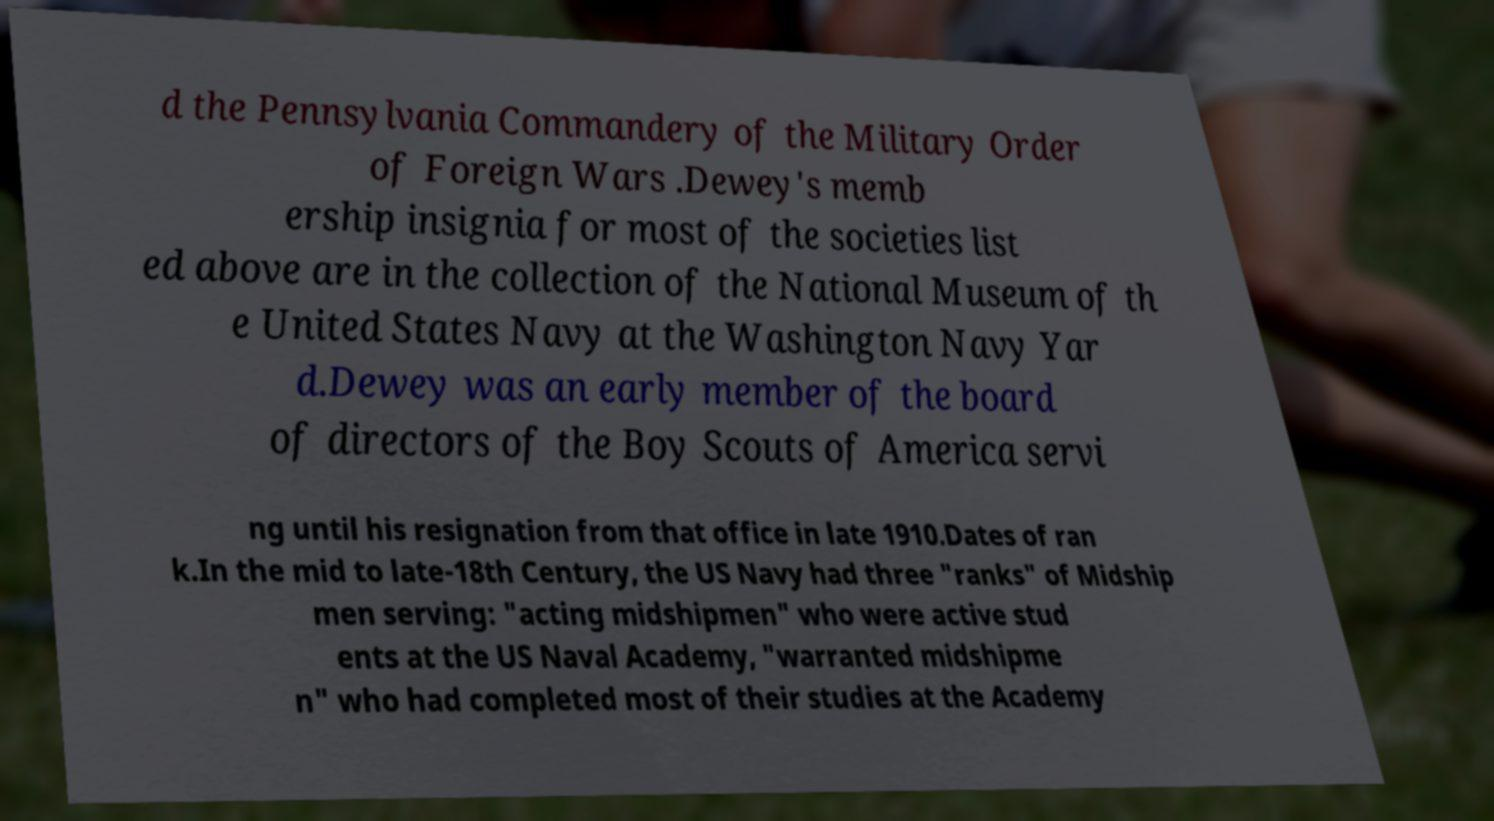For documentation purposes, I need the text within this image transcribed. Could you provide that? d the Pennsylvania Commandery of the Military Order of Foreign Wars .Dewey's memb ership insignia for most of the societies list ed above are in the collection of the National Museum of th e United States Navy at the Washington Navy Yar d.Dewey was an early member of the board of directors of the Boy Scouts of America servi ng until his resignation from that office in late 1910.Dates of ran k.In the mid to late-18th Century, the US Navy had three "ranks" of Midship men serving: "acting midshipmen" who were active stud ents at the US Naval Academy, "warranted midshipme n" who had completed most of their studies at the Academy 